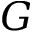<formula> <loc_0><loc_0><loc_500><loc_500>G</formula> 